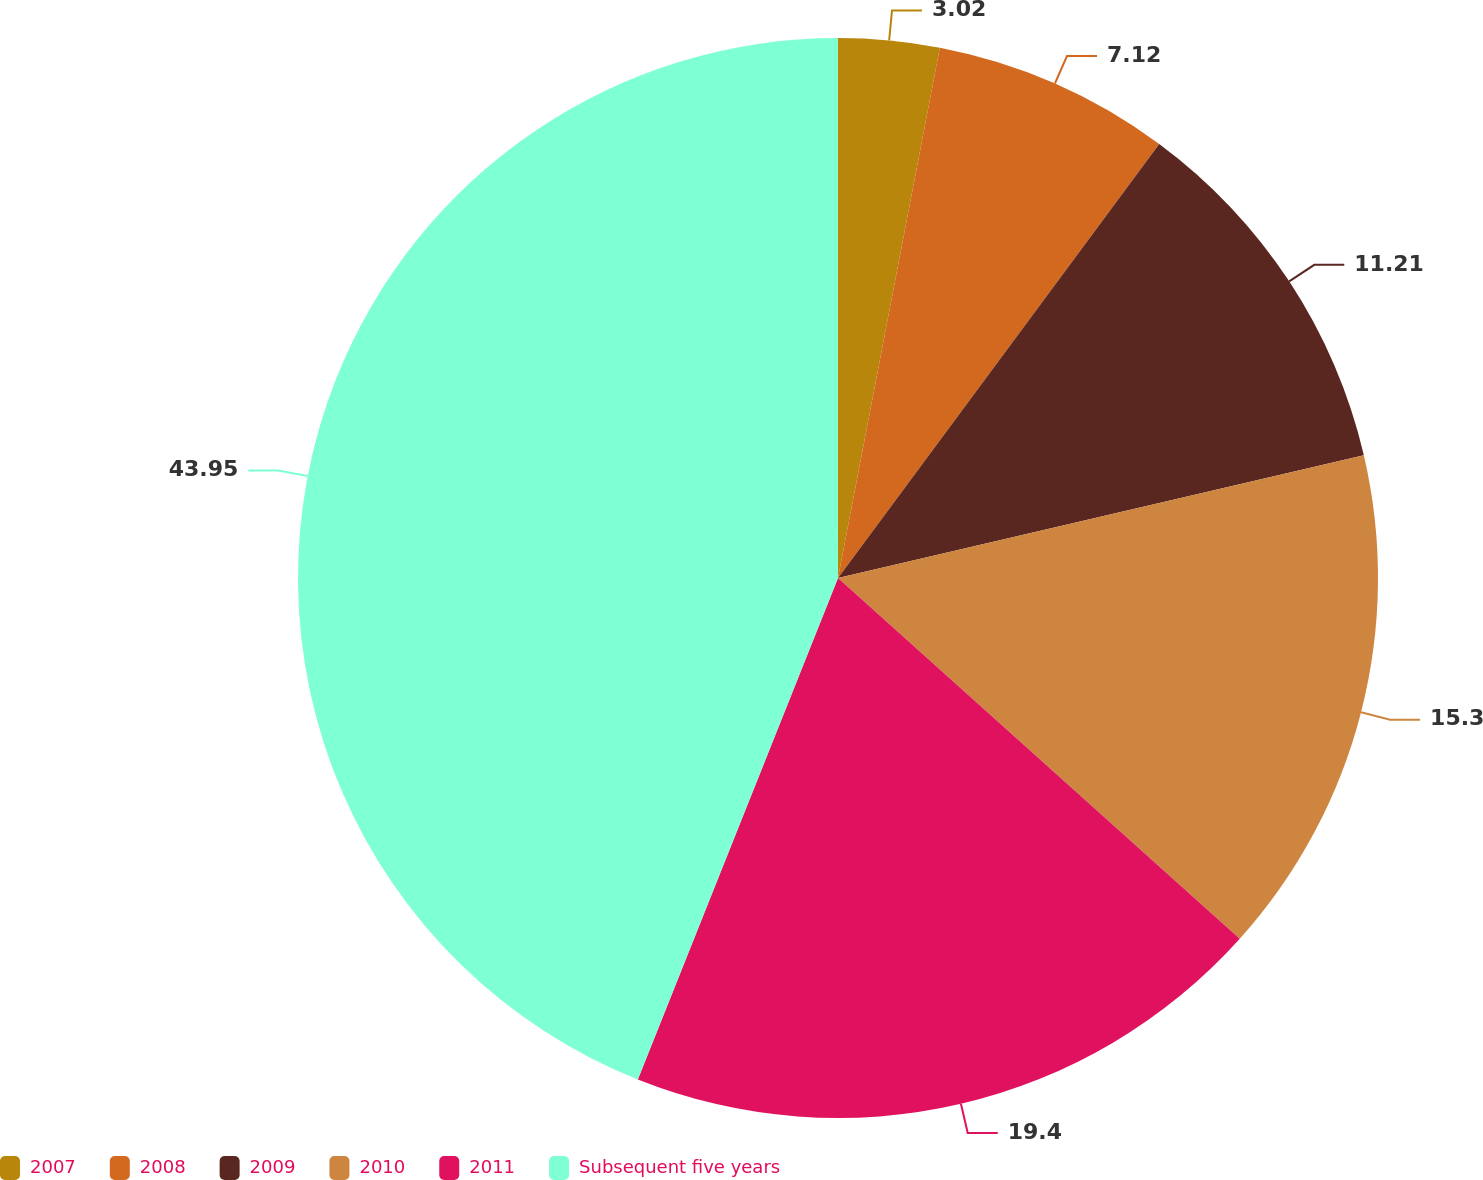<chart> <loc_0><loc_0><loc_500><loc_500><pie_chart><fcel>2007<fcel>2008<fcel>2009<fcel>2010<fcel>2011<fcel>Subsequent five years<nl><fcel>3.02%<fcel>7.12%<fcel>11.21%<fcel>15.3%<fcel>19.4%<fcel>43.96%<nl></chart> 